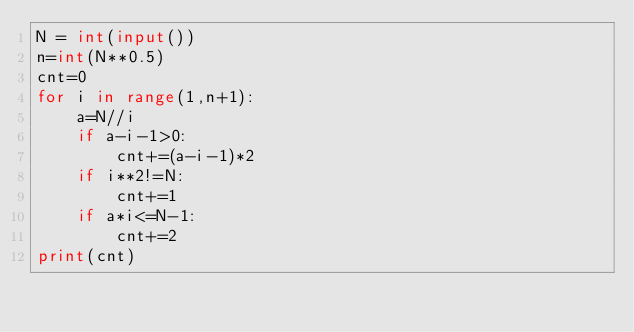<code> <loc_0><loc_0><loc_500><loc_500><_Python_>N = int(input())
n=int(N**0.5)
cnt=0
for i in range(1,n+1):
    a=N//i
    if a-i-1>0:
        cnt+=(a-i-1)*2
    if i**2!=N:
        cnt+=1
    if a*i<=N-1:
        cnt+=2
print(cnt)</code> 